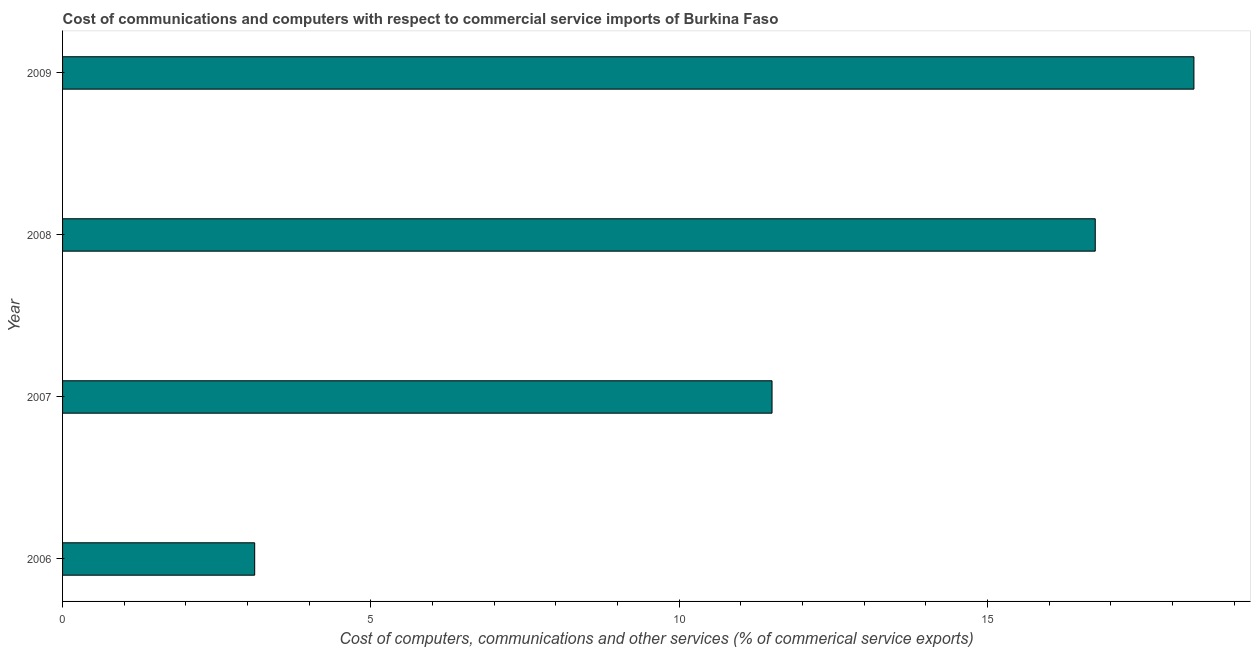Does the graph contain any zero values?
Offer a terse response. No. What is the title of the graph?
Make the answer very short. Cost of communications and computers with respect to commercial service imports of Burkina Faso. What is the label or title of the X-axis?
Provide a succinct answer. Cost of computers, communications and other services (% of commerical service exports). What is the label or title of the Y-axis?
Your response must be concise. Year. What is the  computer and other services in 2009?
Keep it short and to the point. 18.35. Across all years, what is the maximum  computer and other services?
Your answer should be very brief. 18.35. Across all years, what is the minimum  computer and other services?
Provide a succinct answer. 3.12. In which year was the  computer and other services minimum?
Give a very brief answer. 2006. What is the sum of the cost of communications?
Ensure brevity in your answer.  49.71. What is the difference between the cost of communications in 2006 and 2009?
Keep it short and to the point. -15.23. What is the average  computer and other services per year?
Your answer should be very brief. 12.43. What is the median cost of communications?
Give a very brief answer. 14.13. In how many years, is the cost of communications greater than 7 %?
Offer a very short reply. 3. What is the ratio of the cost of communications in 2006 to that in 2008?
Make the answer very short. 0.19. Is the difference between the  computer and other services in 2006 and 2008 greater than the difference between any two years?
Offer a very short reply. No. What is the difference between the highest and the lowest cost of communications?
Your answer should be compact. 15.23. In how many years, is the  computer and other services greater than the average  computer and other services taken over all years?
Your response must be concise. 2. Are all the bars in the graph horizontal?
Offer a very short reply. Yes. Are the values on the major ticks of X-axis written in scientific E-notation?
Keep it short and to the point. No. What is the Cost of computers, communications and other services (% of commerical service exports) of 2006?
Make the answer very short. 3.12. What is the Cost of computers, communications and other services (% of commerical service exports) in 2007?
Your answer should be very brief. 11.51. What is the Cost of computers, communications and other services (% of commerical service exports) in 2008?
Make the answer very short. 16.75. What is the Cost of computers, communications and other services (% of commerical service exports) of 2009?
Give a very brief answer. 18.35. What is the difference between the Cost of computers, communications and other services (% of commerical service exports) in 2006 and 2007?
Your answer should be very brief. -8.39. What is the difference between the Cost of computers, communications and other services (% of commerical service exports) in 2006 and 2008?
Offer a very short reply. -13.63. What is the difference between the Cost of computers, communications and other services (% of commerical service exports) in 2006 and 2009?
Provide a succinct answer. -15.23. What is the difference between the Cost of computers, communications and other services (% of commerical service exports) in 2007 and 2008?
Offer a very short reply. -5.24. What is the difference between the Cost of computers, communications and other services (% of commerical service exports) in 2007 and 2009?
Ensure brevity in your answer.  -6.84. What is the difference between the Cost of computers, communications and other services (% of commerical service exports) in 2008 and 2009?
Keep it short and to the point. -1.6. What is the ratio of the Cost of computers, communications and other services (% of commerical service exports) in 2006 to that in 2007?
Offer a terse response. 0.27. What is the ratio of the Cost of computers, communications and other services (% of commerical service exports) in 2006 to that in 2008?
Provide a short and direct response. 0.19. What is the ratio of the Cost of computers, communications and other services (% of commerical service exports) in 2006 to that in 2009?
Your response must be concise. 0.17. What is the ratio of the Cost of computers, communications and other services (% of commerical service exports) in 2007 to that in 2008?
Make the answer very short. 0.69. What is the ratio of the Cost of computers, communications and other services (% of commerical service exports) in 2007 to that in 2009?
Give a very brief answer. 0.63. What is the ratio of the Cost of computers, communications and other services (% of commerical service exports) in 2008 to that in 2009?
Offer a very short reply. 0.91. 